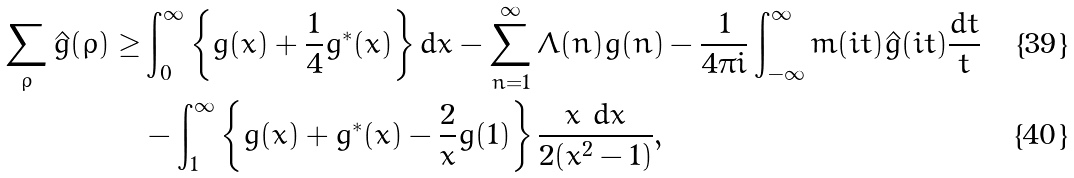Convert formula to latex. <formula><loc_0><loc_0><loc_500><loc_500>\sum _ { \rho } \hat { g } ( \rho ) \geq & \int _ { 0 } ^ { \infty } \left \{ g ( x ) + \frac { 1 } { 4 } g ^ { * } ( x ) \right \} d x - \sum _ { n = 1 } ^ { \infty } \Lambda ( n ) g ( n ) - \frac { 1 } { 4 \pi i } \int ^ { \infty } _ { - \infty } m ( i t ) \hat { g } ( i t ) \frac { d t } { t } \\ & - \int _ { 1 } ^ { \infty } \left \{ g ( x ) + g ^ { * } ( x ) - \frac { 2 } { x } g ( 1 ) \right \} \frac { x \ d x } { 2 ( x ^ { 2 } - 1 ) } ,</formula> 